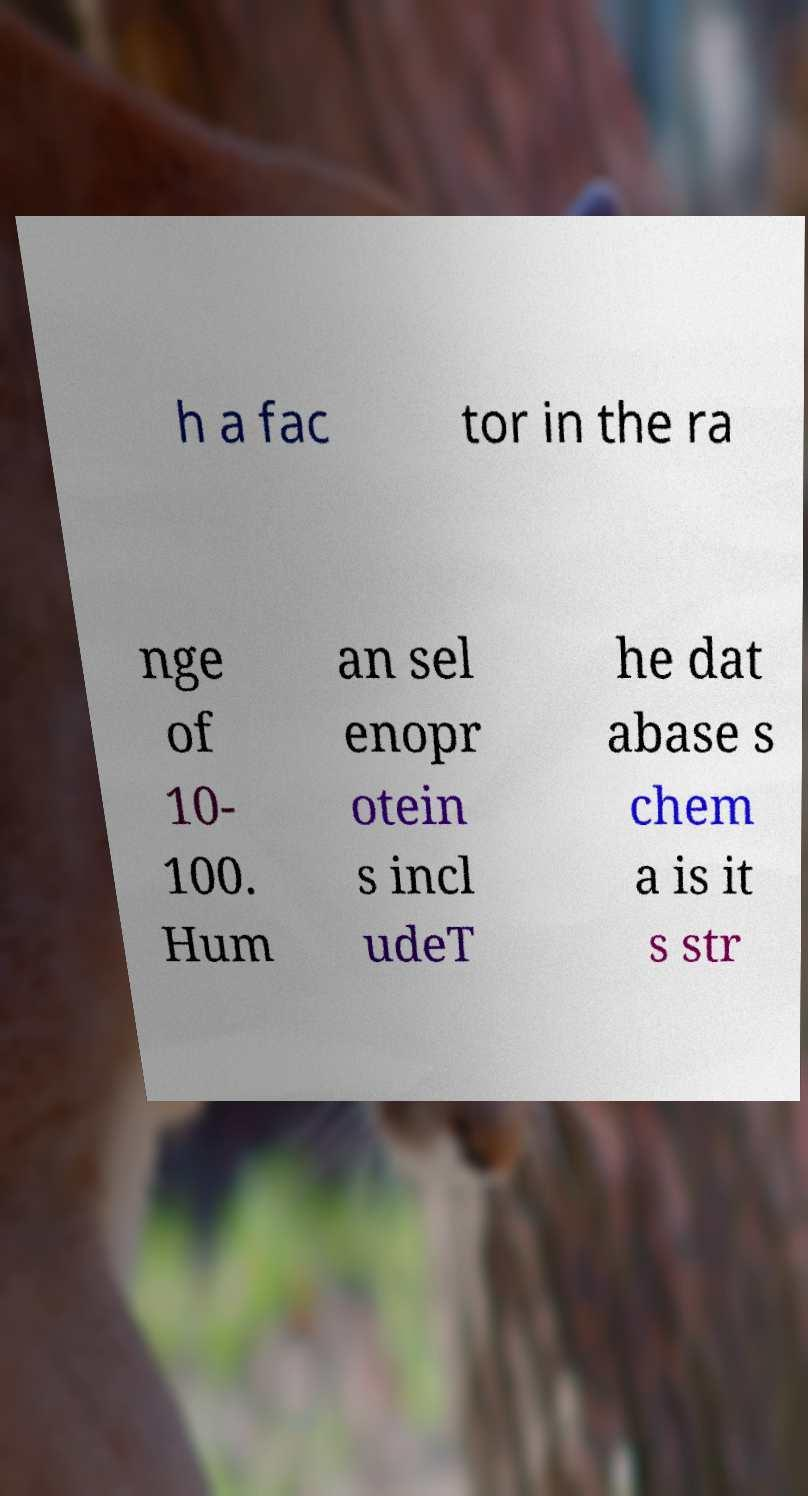For documentation purposes, I need the text within this image transcribed. Could you provide that? h a fac tor in the ra nge of 10- 100. Hum an sel enopr otein s incl udeT he dat abase s chem a is it s str 